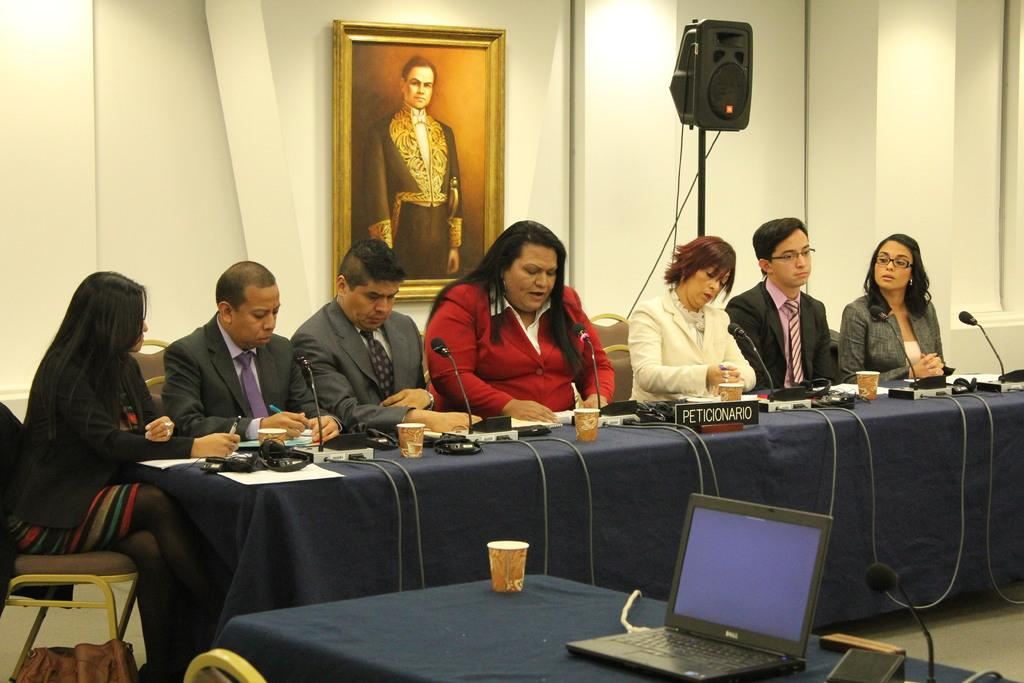<image>
Render a clear and concise summary of the photo. people at a table with sign Peticionario on it 